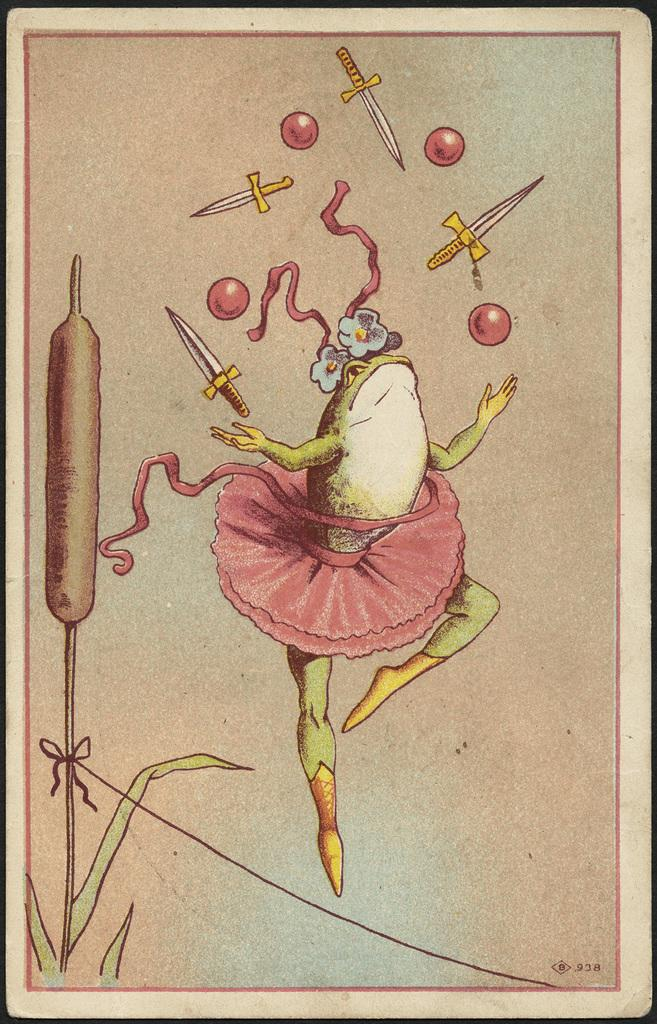What animal is depicted in the image? There is a depiction of a frog in the image. What objects are present in the image besides the frog? There are knives in the image. What color can be observed in the image? There are red-colored things in the image. What type of toys can be seen in the image? There are no toys present in the image. What kind of van is visible in the image? There is no van present in the image. 